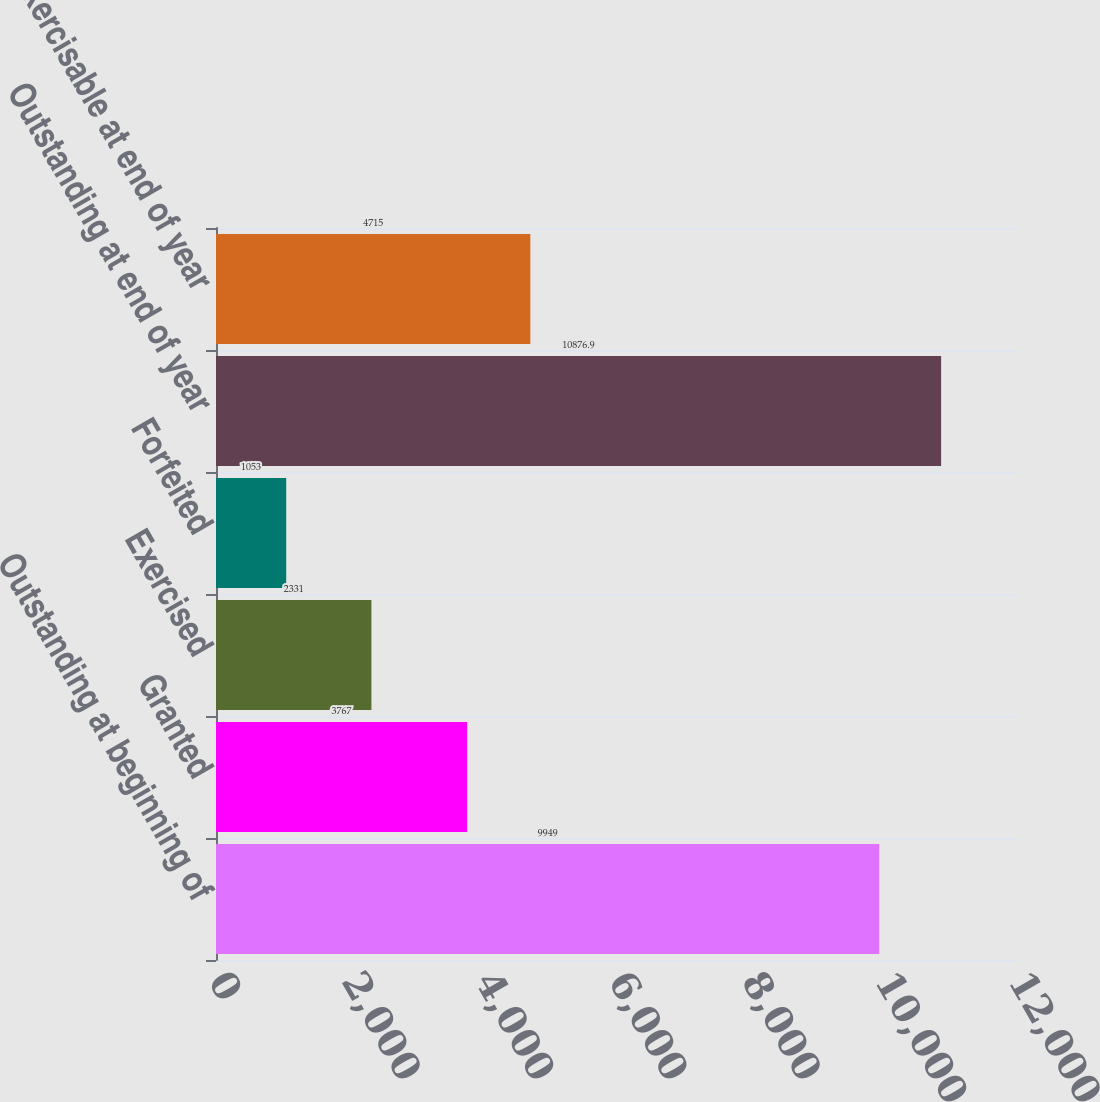Convert chart. <chart><loc_0><loc_0><loc_500><loc_500><bar_chart><fcel>Outstanding at beginning of<fcel>Granted<fcel>Exercised<fcel>Forfeited<fcel>Outstanding at end of year<fcel>Exercisable at end of year<nl><fcel>9949<fcel>3767<fcel>2331<fcel>1053<fcel>10876.9<fcel>4715<nl></chart> 